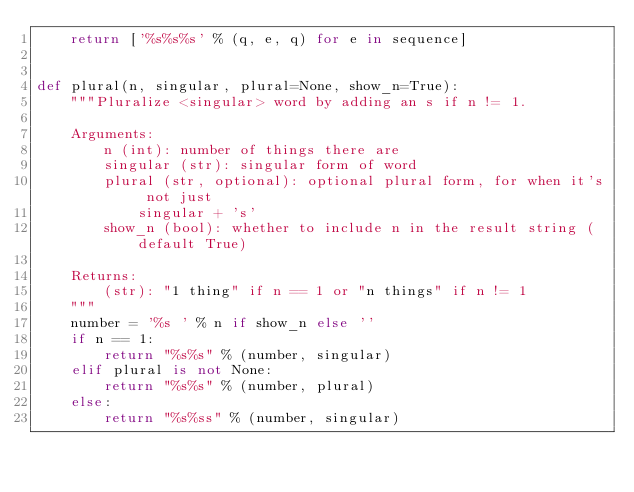Convert code to text. <code><loc_0><loc_0><loc_500><loc_500><_Python_>    return ['%s%s%s' % (q, e, q) for e in sequence]


def plural(n, singular, plural=None, show_n=True):
    """Pluralize <singular> word by adding an s if n != 1.

    Arguments:
        n (int): number of things there are
        singular (str): singular form of word
        plural (str, optional): optional plural form, for when it's not just
            singular + 's'
        show_n (bool): whether to include n in the result string (default True)

    Returns:
        (str): "1 thing" if n == 1 or "n things" if n != 1
    """
    number = '%s ' % n if show_n else ''
    if n == 1:
        return "%s%s" % (number, singular)
    elif plural is not None:
        return "%s%s" % (number, plural)
    else:
        return "%s%ss" % (number, singular)
</code> 